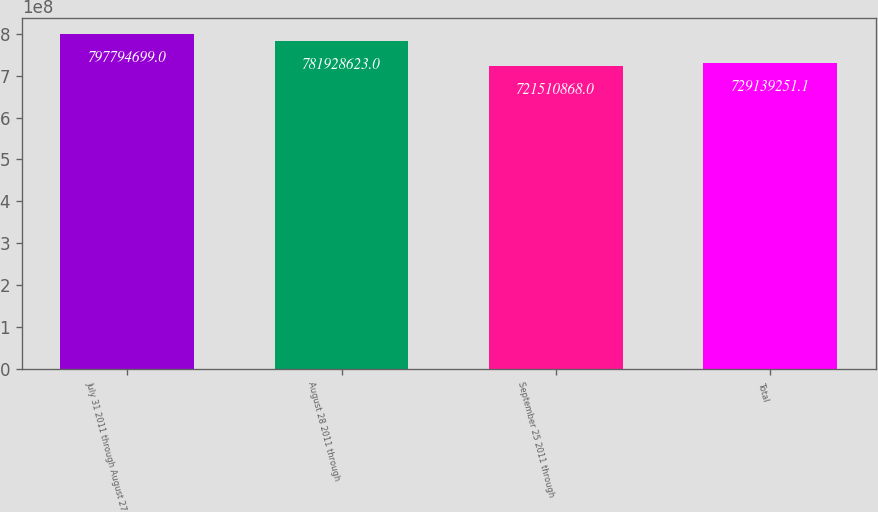<chart> <loc_0><loc_0><loc_500><loc_500><bar_chart><fcel>July 31 2011 through August 27<fcel>August 28 2011 through<fcel>September 25 2011 through<fcel>Total<nl><fcel>7.97795e+08<fcel>7.81929e+08<fcel>7.21511e+08<fcel>7.29139e+08<nl></chart> 